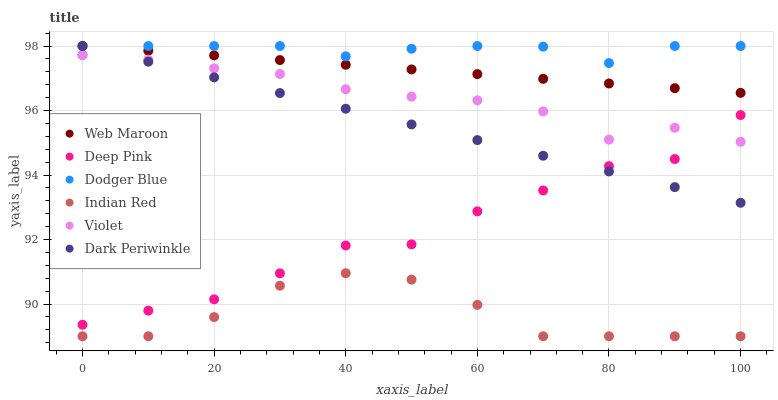Does Indian Red have the minimum area under the curve?
Answer yes or no. Yes. Does Dodger Blue have the maximum area under the curve?
Answer yes or no. Yes. Does Web Maroon have the minimum area under the curve?
Answer yes or no. No. Does Web Maroon have the maximum area under the curve?
Answer yes or no. No. Is Web Maroon the smoothest?
Answer yes or no. Yes. Is Deep Pink the roughest?
Answer yes or no. Yes. Is Dodger Blue the smoothest?
Answer yes or no. No. Is Dodger Blue the roughest?
Answer yes or no. No. Does Indian Red have the lowest value?
Answer yes or no. Yes. Does Web Maroon have the lowest value?
Answer yes or no. No. Does Dark Periwinkle have the highest value?
Answer yes or no. Yes. Does Indian Red have the highest value?
Answer yes or no. No. Is Indian Red less than Dark Periwinkle?
Answer yes or no. Yes. Is Violet greater than Indian Red?
Answer yes or no. Yes. Does Web Maroon intersect Dark Periwinkle?
Answer yes or no. Yes. Is Web Maroon less than Dark Periwinkle?
Answer yes or no. No. Is Web Maroon greater than Dark Periwinkle?
Answer yes or no. No. Does Indian Red intersect Dark Periwinkle?
Answer yes or no. No. 